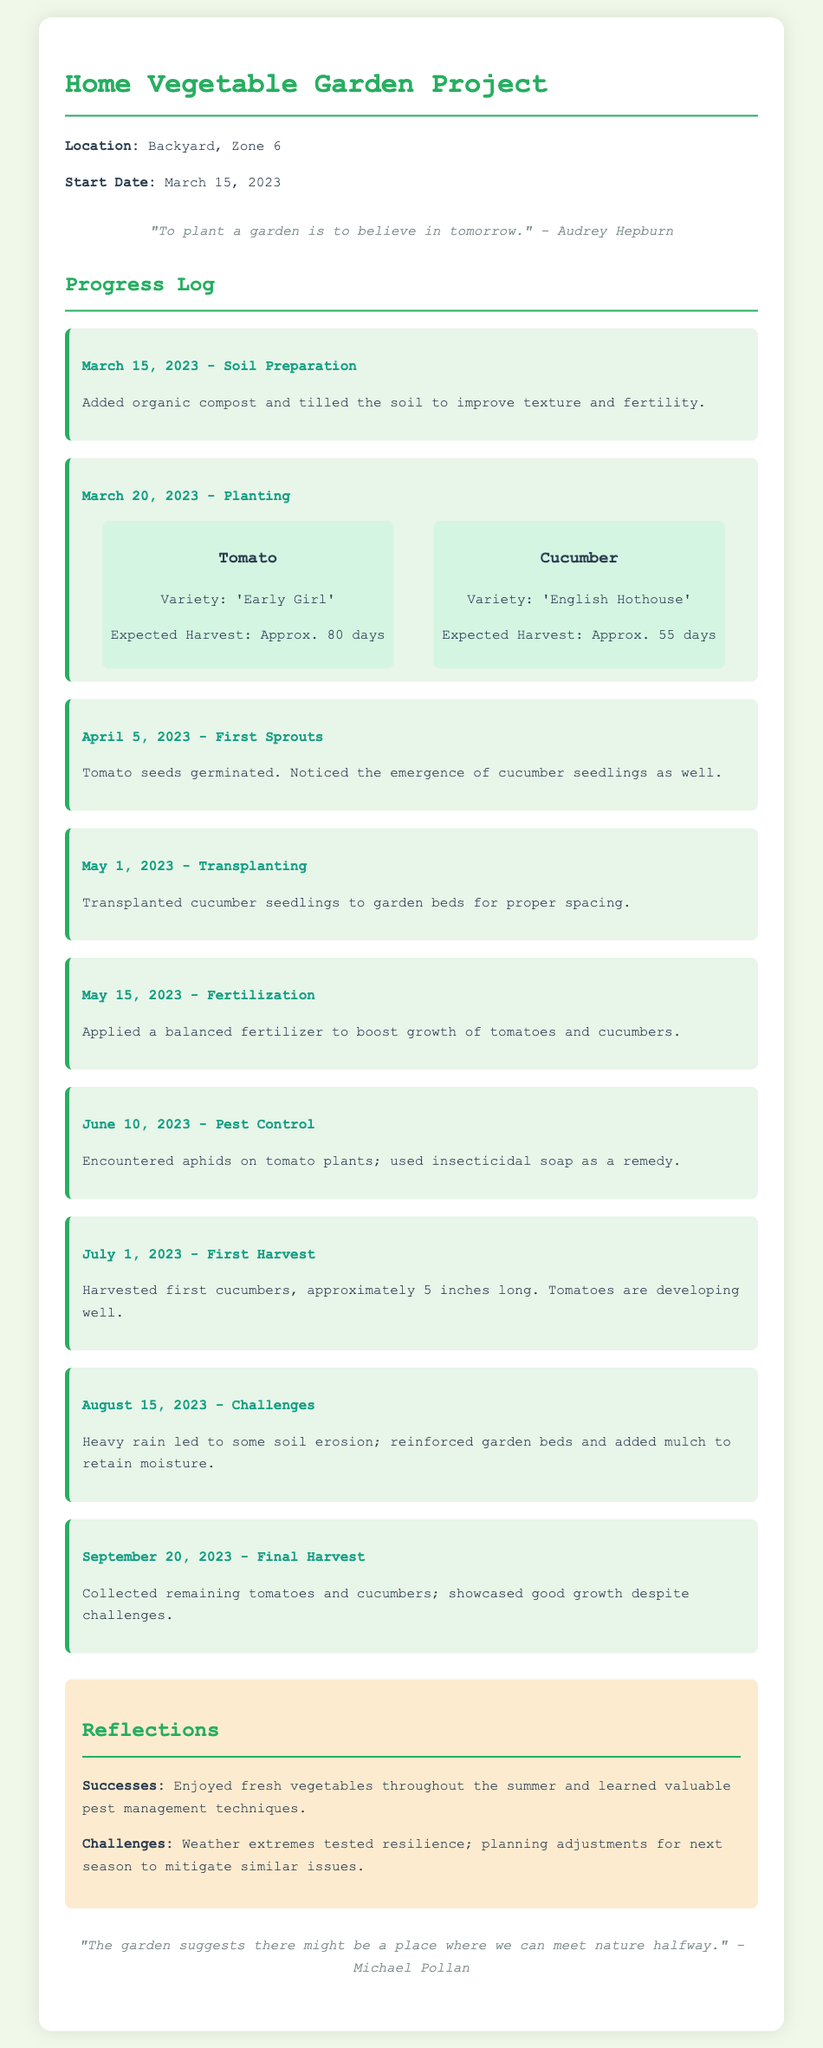What is the start date of the garden project? The start date is mentioned in the document as March 15, 2023.
Answer: March 15, 2023 What vegetable variety was planted on March 20, 2023? The document lists the variety 'Early Girl' for tomatoes and 'English Hothouse' for cucumbers.
Answer: 'Early Girl' and 'English Hothouse' What was the date of the first harvest? The document specifies the first harvest took place on July 1, 2023.
Answer: July 1, 2023 What challenge was faced on August 15, 2023? The document notes that heavy rain led to soil erosion, which was a challenge faced at that time.
Answer: Heavy rain and soil erosion How did the gardener manage pests on the tomato plants? The log entry describes that insecticidal soap was used as a remedy for aphids on tomato plants.
Answer: Insecticidal soap List one success mentioned in the reflections. The document states that fresh vegetables were enjoyed throughout the summer.
Answer: Enjoyed fresh vegetables What are the expected harvest days for cucumbers? The document states that cucumbers have an expected harvest time of approximately 55 days.
Answer: Approximately 55 days What did the gardener apply on May 15, 2023, to boost growth? The log entry specifies that a balanced fertilizer was applied for this purpose.
Answer: Balanced fertilizer What were the garden's location and zone? The document describes the garden's location as the backyard and the zone as Zone 6.
Answer: Backyard, Zone 6 